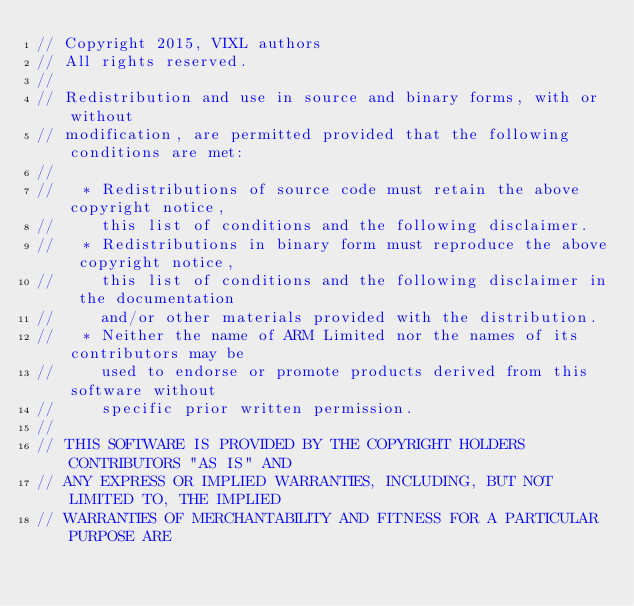<code> <loc_0><loc_0><loc_500><loc_500><_C_>// Copyright 2015, VIXL authors
// All rights reserved.
//
// Redistribution and use in source and binary forms, with or without
// modification, are permitted provided that the following conditions are met:
//
//   * Redistributions of source code must retain the above copyright notice,
//     this list of conditions and the following disclaimer.
//   * Redistributions in binary form must reproduce the above copyright notice,
//     this list of conditions and the following disclaimer in the documentation
//     and/or other materials provided with the distribution.
//   * Neither the name of ARM Limited nor the names of its contributors may be
//     used to endorse or promote products derived from this software without
//     specific prior written permission.
//
// THIS SOFTWARE IS PROVIDED BY THE COPYRIGHT HOLDERS CONTRIBUTORS "AS IS" AND
// ANY EXPRESS OR IMPLIED WARRANTIES, INCLUDING, BUT NOT LIMITED TO, THE IMPLIED
// WARRANTIES OF MERCHANTABILITY AND FITNESS FOR A PARTICULAR PURPOSE ARE</code> 